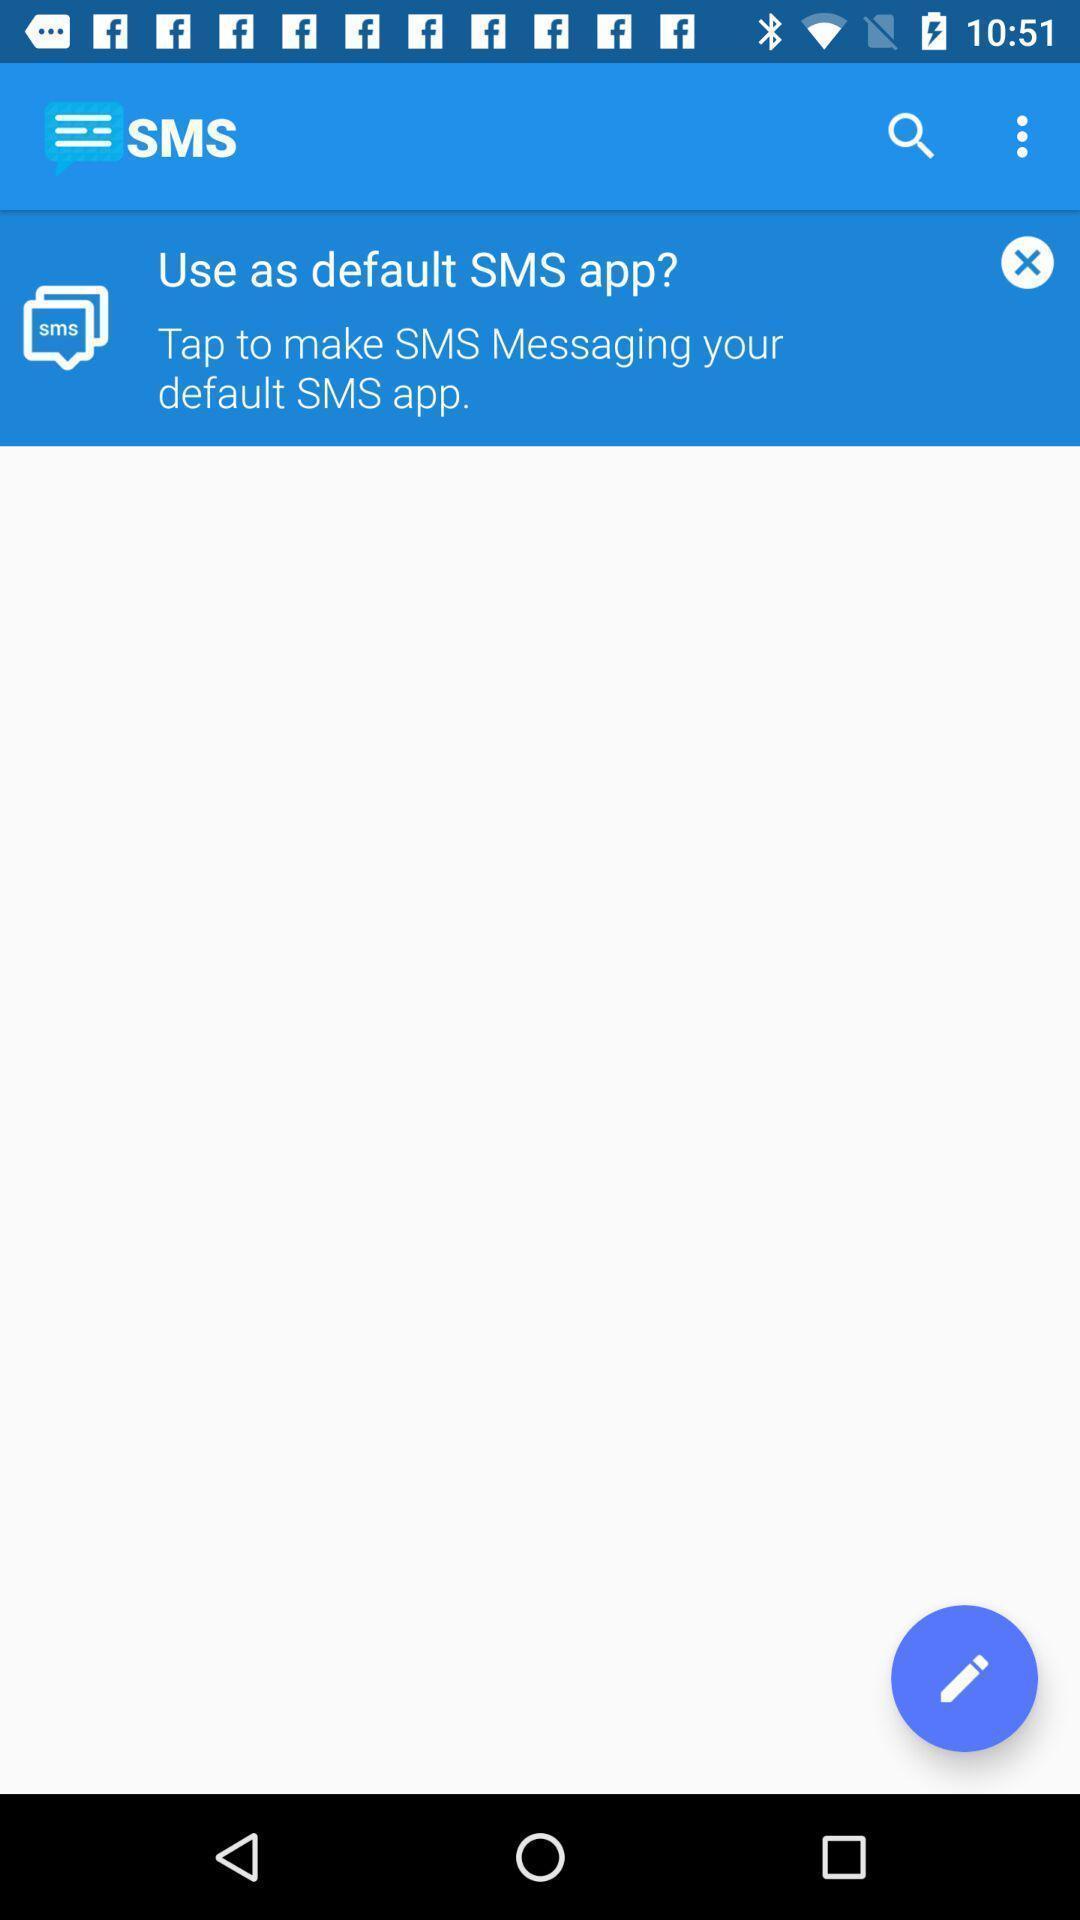Provide a description of this screenshot. Sms page. 